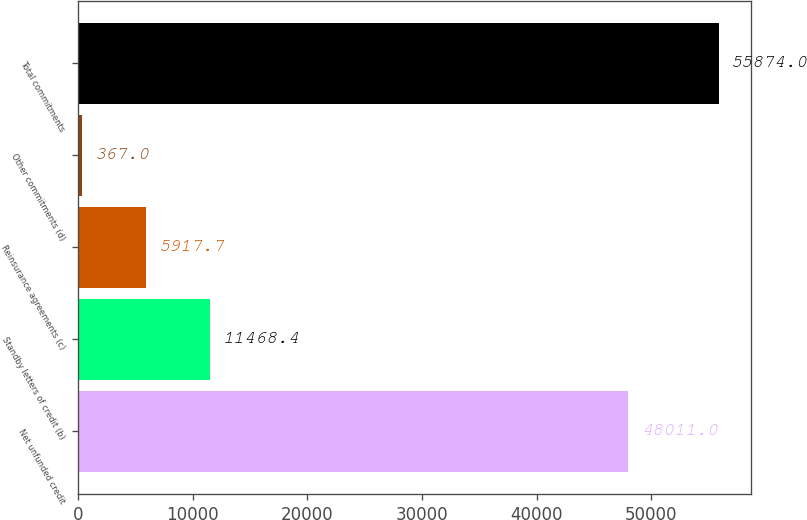<chart> <loc_0><loc_0><loc_500><loc_500><bar_chart><fcel>Net unfunded credit<fcel>Standby letters of credit (b)<fcel>Reinsurance agreements (c)<fcel>Other commitments (d)<fcel>Total commitments<nl><fcel>48011<fcel>11468.4<fcel>5917.7<fcel>367<fcel>55874<nl></chart> 